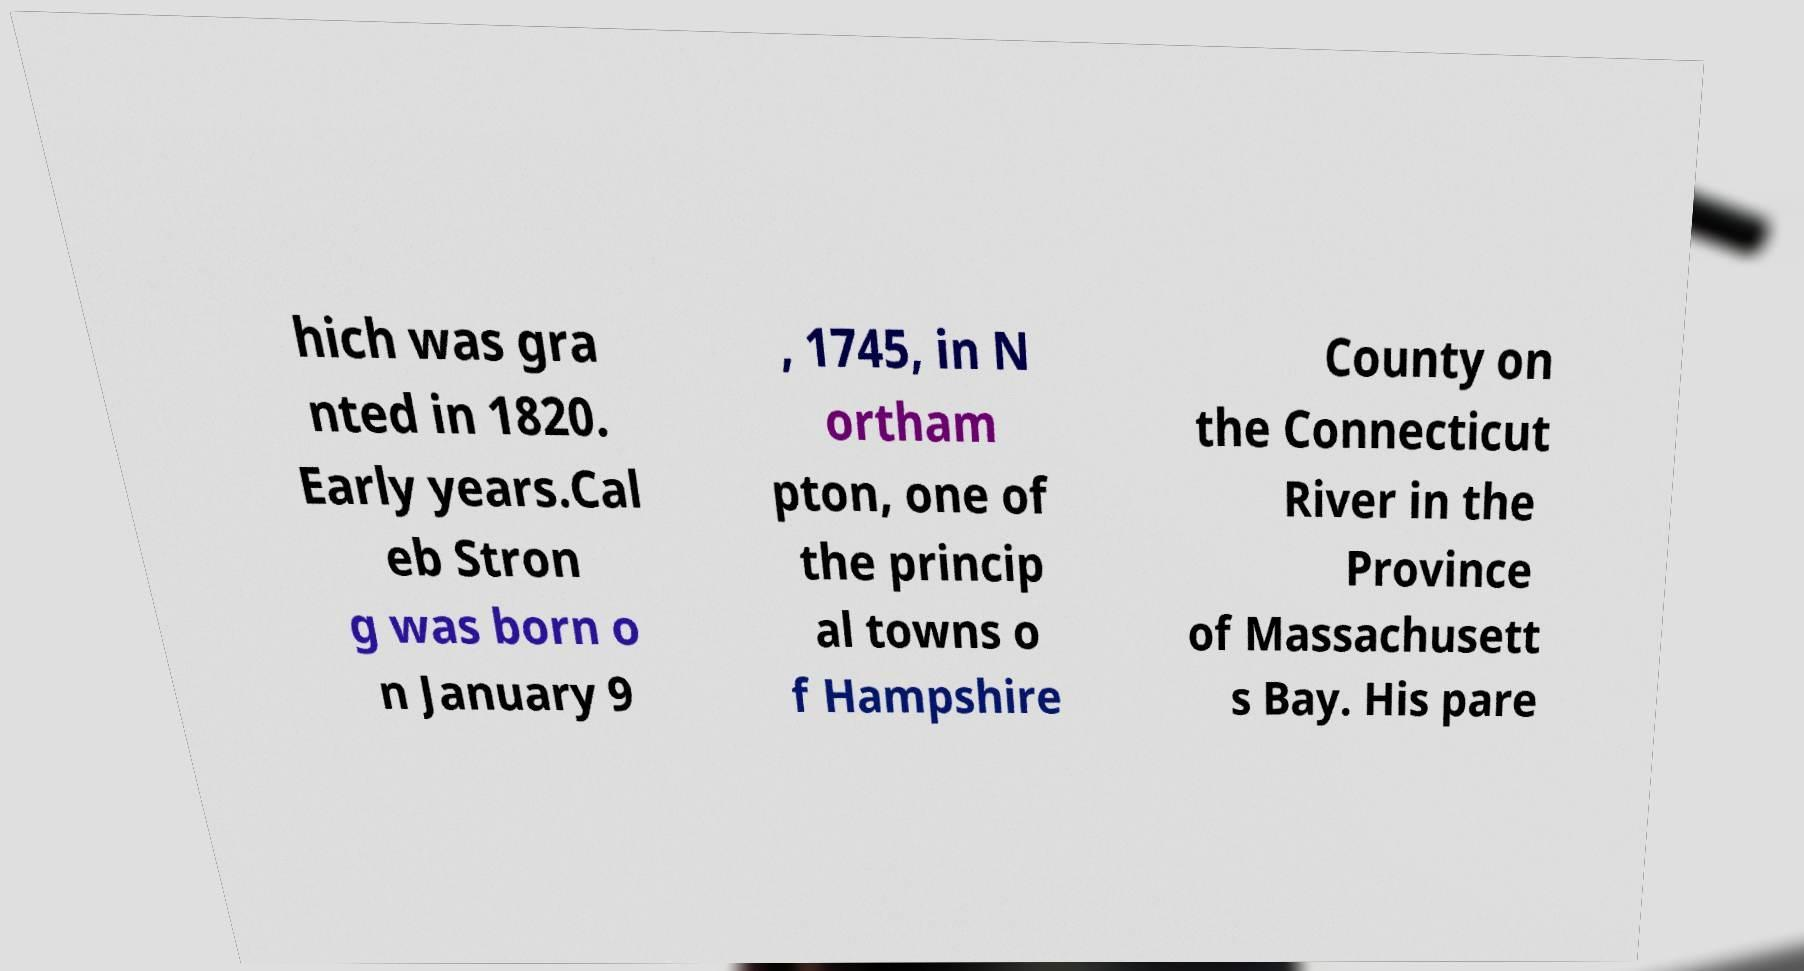Could you extract and type out the text from this image? hich was gra nted in 1820. Early years.Cal eb Stron g was born o n January 9 , 1745, in N ortham pton, one of the princip al towns o f Hampshire County on the Connecticut River in the Province of Massachusett s Bay. His pare 